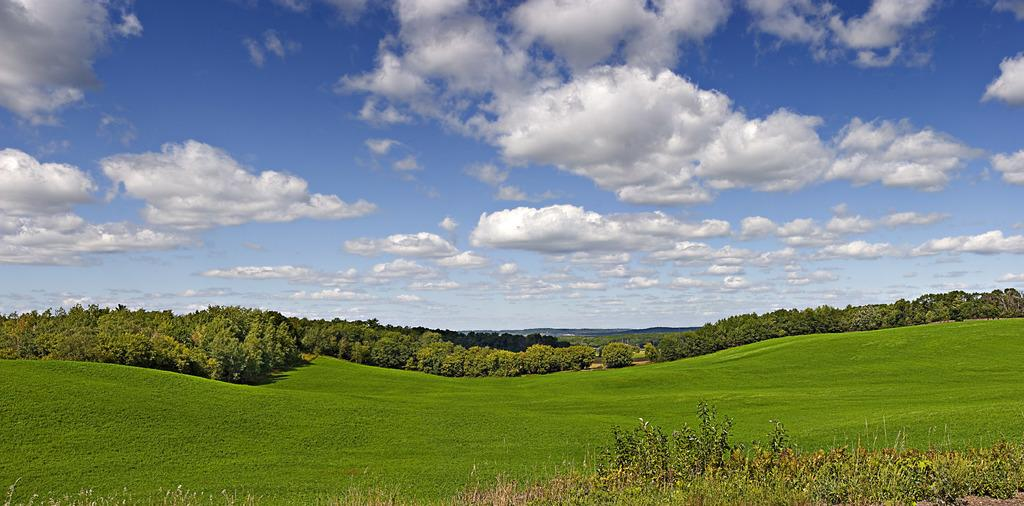What can be seen in the sky in the image? There is a beautiful view of clouds in the sky. What type of vegetation is visible in the image? There is grass visible in the image. What other natural elements can be seen in the image? There are trees present in the image. What type of wire can be seen connecting the clouds in the image? There is no wire connecting the clouds in the image; it is a natural view of clouds in the sky. 